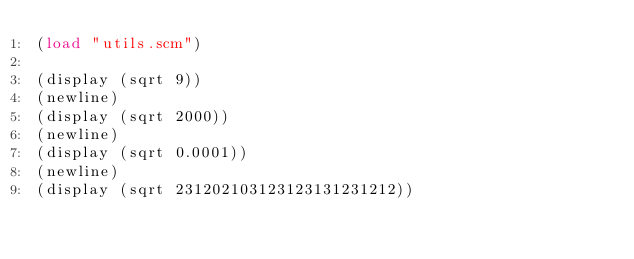<code> <loc_0><loc_0><loc_500><loc_500><_Scheme_>(load "utils.scm")

(display (sqrt 9))
(newline)
(display (sqrt 2000))
(newline)
(display (sqrt 0.0001))
(newline)
(display (sqrt 231202103123123131231212))
</code> 